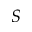<formula> <loc_0><loc_0><loc_500><loc_500>S</formula> 